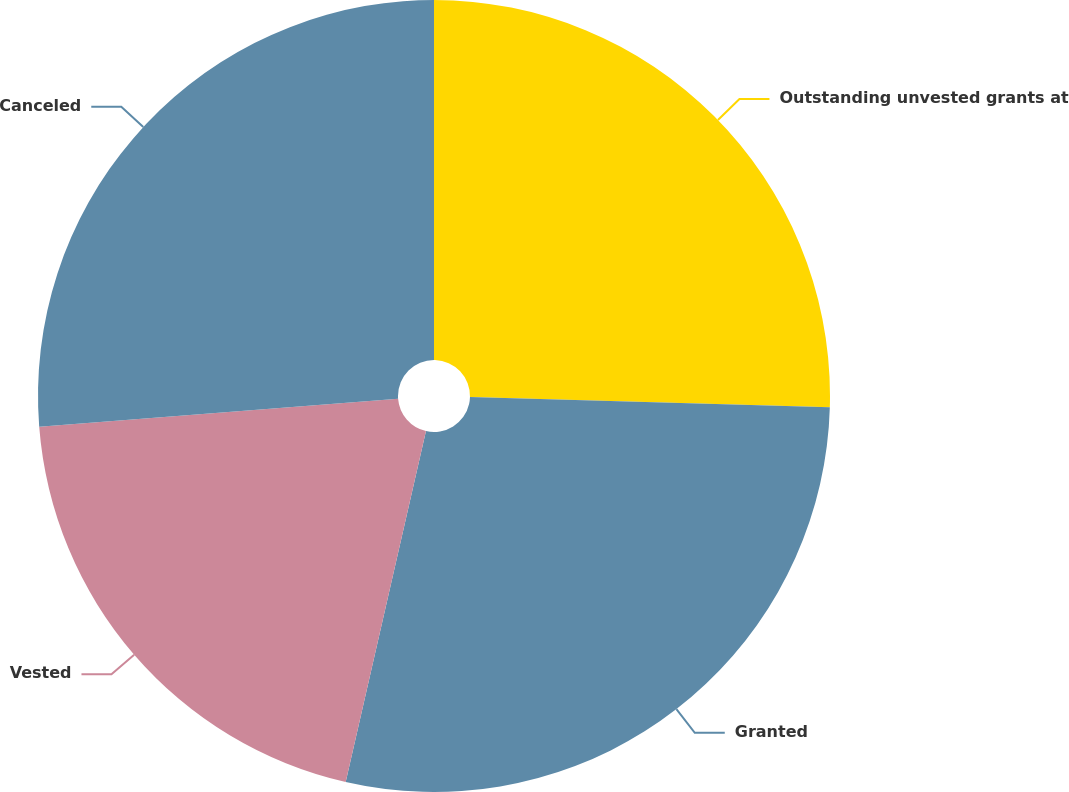<chart> <loc_0><loc_0><loc_500><loc_500><pie_chart><fcel>Outstanding unvested grants at<fcel>Granted<fcel>Vested<fcel>Canceled<nl><fcel>25.45%<fcel>28.13%<fcel>20.18%<fcel>26.24%<nl></chart> 